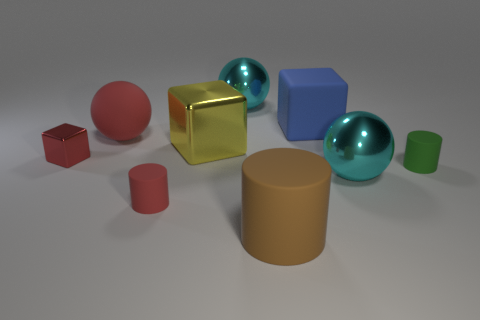Subtract all green balls. Subtract all gray blocks. How many balls are left? 3 Add 1 big blue matte cubes. How many objects exist? 10 Subtract all cylinders. How many objects are left? 6 Subtract all big metallic balls. Subtract all metal balls. How many objects are left? 5 Add 7 tiny objects. How many tiny objects are left? 10 Add 8 small purple balls. How many small purple balls exist? 8 Subtract 1 red balls. How many objects are left? 8 